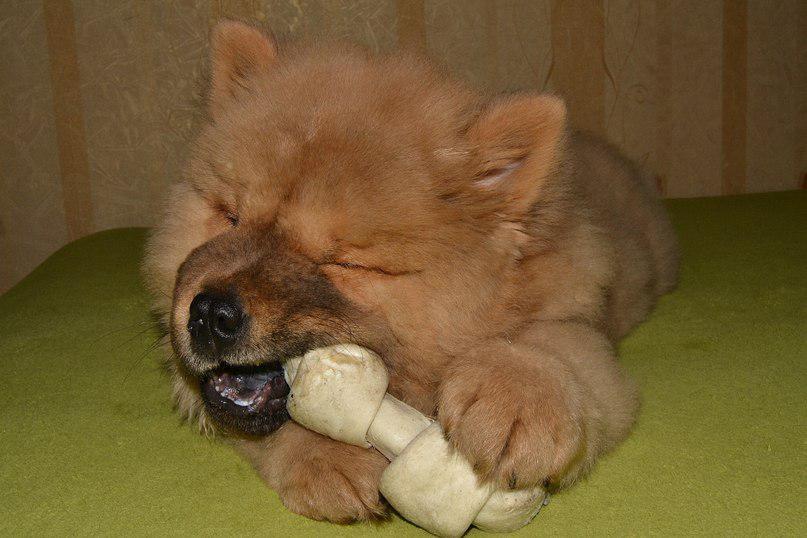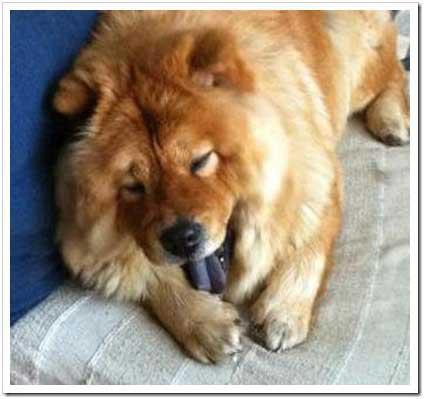The first image is the image on the left, the second image is the image on the right. Analyze the images presented: Is the assertion "A dog is eating food." valid? Answer yes or no. No. The first image is the image on the left, the second image is the image on the right. For the images displayed, is the sentence "there are 3 dogs in the image pair" factually correct? Answer yes or no. No. 